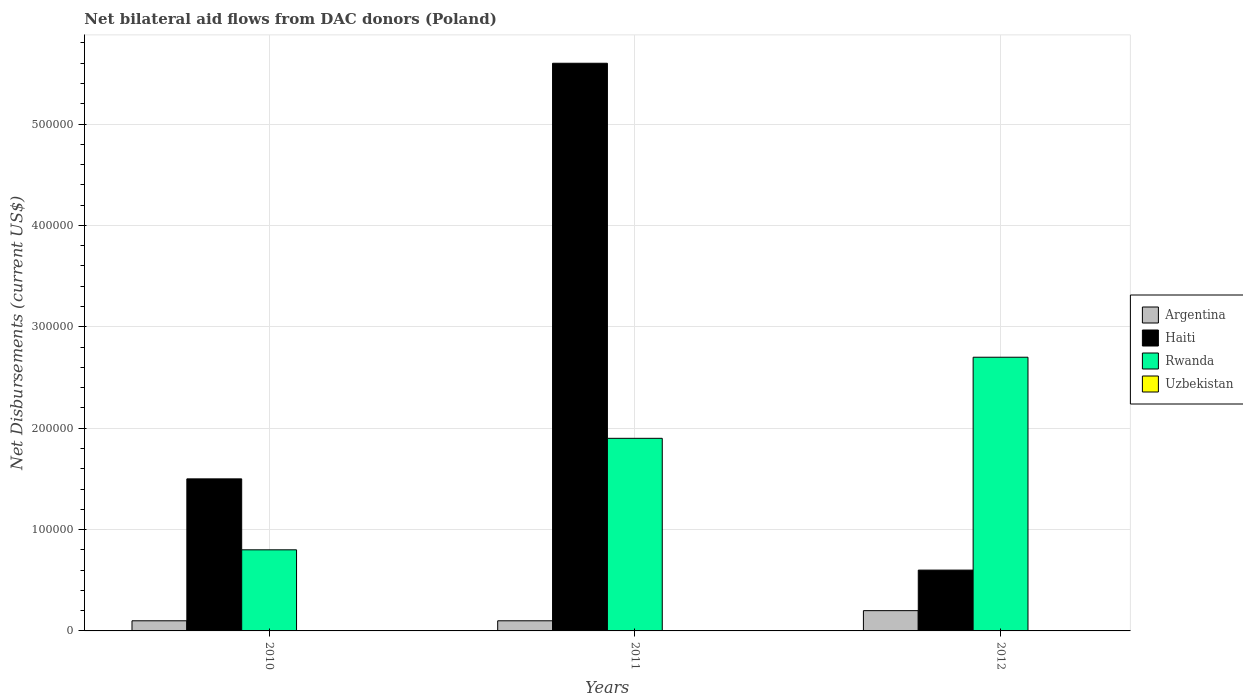Are the number of bars on each tick of the X-axis equal?
Your answer should be very brief. Yes. How many bars are there on the 1st tick from the left?
Keep it short and to the point. 3. What is the label of the 1st group of bars from the left?
Offer a terse response. 2010. What is the net bilateral aid flows in Argentina in 2012?
Make the answer very short. 2.00e+04. Across all years, what is the maximum net bilateral aid flows in Rwanda?
Make the answer very short. 2.70e+05. What is the difference between the net bilateral aid flows in Rwanda in 2010 and that in 2011?
Offer a terse response. -1.10e+05. What is the difference between the net bilateral aid flows in Argentina in 2011 and the net bilateral aid flows in Rwanda in 2012?
Keep it short and to the point. -2.60e+05. In the year 2010, what is the difference between the net bilateral aid flows in Rwanda and net bilateral aid flows in Haiti?
Make the answer very short. -7.00e+04. What is the ratio of the net bilateral aid flows in Rwanda in 2010 to that in 2011?
Provide a succinct answer. 0.42. Is the difference between the net bilateral aid flows in Rwanda in 2010 and 2012 greater than the difference between the net bilateral aid flows in Haiti in 2010 and 2012?
Provide a short and direct response. No. What is the difference between the highest and the second highest net bilateral aid flows in Argentina?
Offer a terse response. 10000. What is the difference between the highest and the lowest net bilateral aid flows in Rwanda?
Your answer should be compact. 1.90e+05. In how many years, is the net bilateral aid flows in Rwanda greater than the average net bilateral aid flows in Rwanda taken over all years?
Provide a short and direct response. 2. Is it the case that in every year, the sum of the net bilateral aid flows in Uzbekistan and net bilateral aid flows in Haiti is greater than the sum of net bilateral aid flows in Rwanda and net bilateral aid flows in Argentina?
Ensure brevity in your answer.  No. Is it the case that in every year, the sum of the net bilateral aid flows in Uzbekistan and net bilateral aid flows in Argentina is greater than the net bilateral aid flows in Haiti?
Ensure brevity in your answer.  No. How many bars are there?
Ensure brevity in your answer.  9. Are all the bars in the graph horizontal?
Your response must be concise. No. What is the difference between two consecutive major ticks on the Y-axis?
Your response must be concise. 1.00e+05. Are the values on the major ticks of Y-axis written in scientific E-notation?
Your answer should be compact. No. Does the graph contain grids?
Provide a short and direct response. Yes. Where does the legend appear in the graph?
Ensure brevity in your answer.  Center right. What is the title of the graph?
Make the answer very short. Net bilateral aid flows from DAC donors (Poland). What is the label or title of the X-axis?
Keep it short and to the point. Years. What is the label or title of the Y-axis?
Offer a terse response. Net Disbursements (current US$). What is the Net Disbursements (current US$) in Haiti in 2010?
Make the answer very short. 1.50e+05. What is the Net Disbursements (current US$) of Rwanda in 2010?
Your answer should be very brief. 8.00e+04. What is the Net Disbursements (current US$) of Uzbekistan in 2010?
Offer a terse response. 0. What is the Net Disbursements (current US$) of Argentina in 2011?
Provide a succinct answer. 10000. What is the Net Disbursements (current US$) of Haiti in 2011?
Your answer should be compact. 5.60e+05. What is the Net Disbursements (current US$) in Uzbekistan in 2011?
Provide a succinct answer. 0. What is the Net Disbursements (current US$) in Haiti in 2012?
Keep it short and to the point. 6.00e+04. What is the Net Disbursements (current US$) of Rwanda in 2012?
Provide a short and direct response. 2.70e+05. Across all years, what is the maximum Net Disbursements (current US$) in Argentina?
Your answer should be very brief. 2.00e+04. Across all years, what is the maximum Net Disbursements (current US$) of Haiti?
Make the answer very short. 5.60e+05. Across all years, what is the maximum Net Disbursements (current US$) of Rwanda?
Your answer should be compact. 2.70e+05. Across all years, what is the minimum Net Disbursements (current US$) in Argentina?
Give a very brief answer. 10000. Across all years, what is the minimum Net Disbursements (current US$) in Rwanda?
Provide a short and direct response. 8.00e+04. What is the total Net Disbursements (current US$) in Argentina in the graph?
Make the answer very short. 4.00e+04. What is the total Net Disbursements (current US$) in Haiti in the graph?
Your answer should be compact. 7.70e+05. What is the total Net Disbursements (current US$) in Rwanda in the graph?
Ensure brevity in your answer.  5.40e+05. What is the total Net Disbursements (current US$) of Uzbekistan in the graph?
Keep it short and to the point. 0. What is the difference between the Net Disbursements (current US$) of Haiti in 2010 and that in 2011?
Your answer should be very brief. -4.10e+05. What is the difference between the Net Disbursements (current US$) of Rwanda in 2010 and that in 2012?
Offer a terse response. -1.90e+05. What is the difference between the Net Disbursements (current US$) in Argentina in 2011 and that in 2012?
Ensure brevity in your answer.  -10000. What is the difference between the Net Disbursements (current US$) of Haiti in 2011 and that in 2012?
Offer a terse response. 5.00e+05. What is the difference between the Net Disbursements (current US$) in Argentina in 2010 and the Net Disbursements (current US$) in Haiti in 2011?
Keep it short and to the point. -5.50e+05. What is the difference between the Net Disbursements (current US$) of Argentina in 2010 and the Net Disbursements (current US$) of Rwanda in 2012?
Offer a terse response. -2.60e+05. What is the difference between the Net Disbursements (current US$) of Argentina in 2011 and the Net Disbursements (current US$) of Haiti in 2012?
Provide a succinct answer. -5.00e+04. What is the difference between the Net Disbursements (current US$) of Haiti in 2011 and the Net Disbursements (current US$) of Rwanda in 2012?
Ensure brevity in your answer.  2.90e+05. What is the average Net Disbursements (current US$) in Argentina per year?
Your answer should be very brief. 1.33e+04. What is the average Net Disbursements (current US$) in Haiti per year?
Your response must be concise. 2.57e+05. What is the average Net Disbursements (current US$) of Uzbekistan per year?
Provide a short and direct response. 0. In the year 2010, what is the difference between the Net Disbursements (current US$) of Argentina and Net Disbursements (current US$) of Rwanda?
Ensure brevity in your answer.  -7.00e+04. In the year 2011, what is the difference between the Net Disbursements (current US$) in Argentina and Net Disbursements (current US$) in Haiti?
Your response must be concise. -5.50e+05. In the year 2011, what is the difference between the Net Disbursements (current US$) of Argentina and Net Disbursements (current US$) of Rwanda?
Your answer should be very brief. -1.80e+05. In the year 2012, what is the difference between the Net Disbursements (current US$) of Argentina and Net Disbursements (current US$) of Rwanda?
Provide a succinct answer. -2.50e+05. In the year 2012, what is the difference between the Net Disbursements (current US$) in Haiti and Net Disbursements (current US$) in Rwanda?
Ensure brevity in your answer.  -2.10e+05. What is the ratio of the Net Disbursements (current US$) in Argentina in 2010 to that in 2011?
Provide a short and direct response. 1. What is the ratio of the Net Disbursements (current US$) of Haiti in 2010 to that in 2011?
Provide a short and direct response. 0.27. What is the ratio of the Net Disbursements (current US$) in Rwanda in 2010 to that in 2011?
Ensure brevity in your answer.  0.42. What is the ratio of the Net Disbursements (current US$) of Rwanda in 2010 to that in 2012?
Offer a very short reply. 0.3. What is the ratio of the Net Disbursements (current US$) in Haiti in 2011 to that in 2012?
Provide a short and direct response. 9.33. What is the ratio of the Net Disbursements (current US$) in Rwanda in 2011 to that in 2012?
Provide a succinct answer. 0.7. What is the difference between the highest and the second highest Net Disbursements (current US$) of Argentina?
Provide a succinct answer. 10000. What is the difference between the highest and the second highest Net Disbursements (current US$) in Rwanda?
Your answer should be very brief. 8.00e+04. What is the difference between the highest and the lowest Net Disbursements (current US$) in Argentina?
Your answer should be compact. 10000. What is the difference between the highest and the lowest Net Disbursements (current US$) in Rwanda?
Your response must be concise. 1.90e+05. 